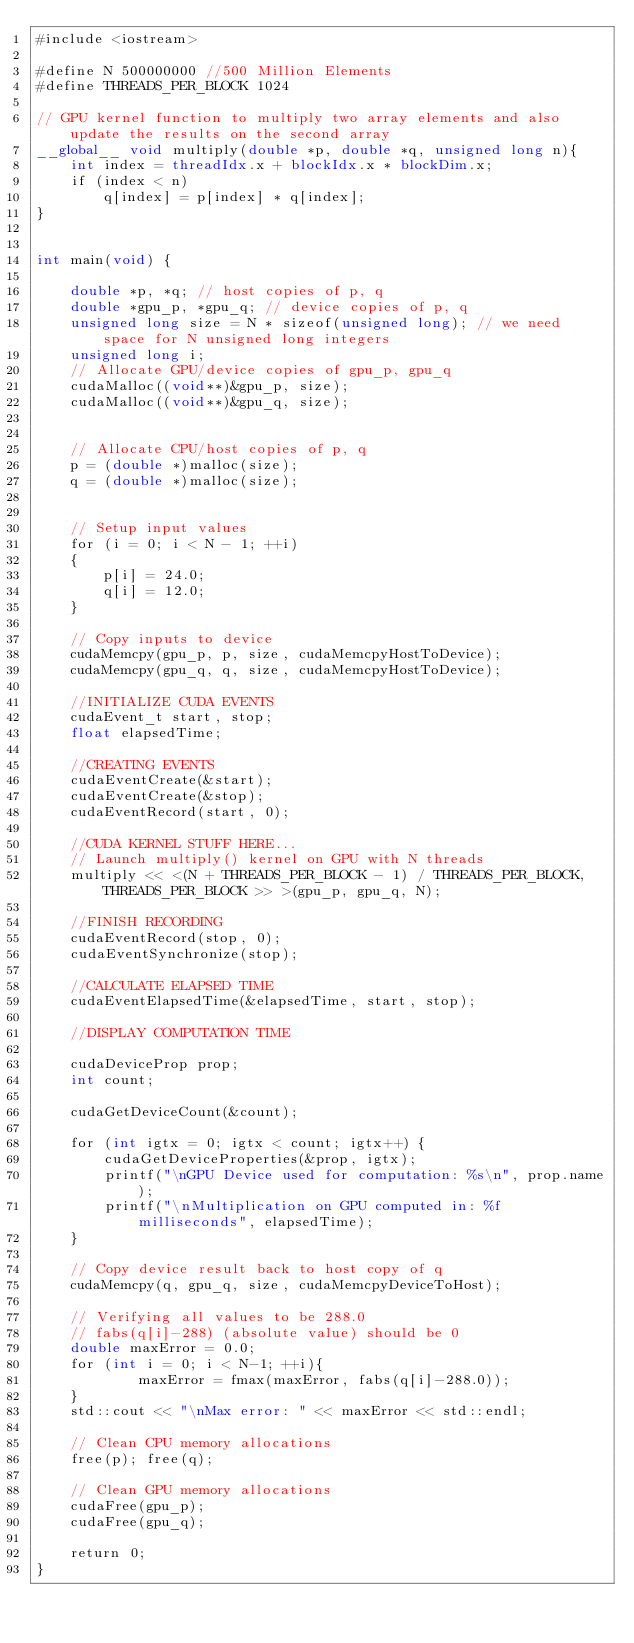Convert code to text. <code><loc_0><loc_0><loc_500><loc_500><_Cuda_>#include <iostream>

#define N 500000000 //500 Million Elements
#define THREADS_PER_BLOCK 1024

// GPU kernel function to multiply two array elements and also update the results on the second array
__global__ void multiply(double *p, double *q, unsigned long n){
	int index = threadIdx.x + blockIdx.x * blockDim.x;
	if (index < n)
		q[index] = p[index] * q[index];
}


int main(void) {

	double *p, *q; // host copies of p, q
	double *gpu_p, *gpu_q; // device copies of p, q
	unsigned long size = N * sizeof(unsigned long); // we need space for N unsigned long integers
	unsigned long i;
	// Allocate GPU/device copies of gpu_p, gpu_q
	cudaMalloc((void**)&gpu_p, size);
	cudaMalloc((void**)&gpu_q, size);


	// Allocate CPU/host copies of p, q
	p = (double *)malloc(size);
	q = (double *)malloc(size);


	// Setup input values
	for (i = 0; i < N - 1; ++i)
	{
		p[i] = 24.0;
		q[i] = 12.0;
	}

	// Copy inputs to device
	cudaMemcpy(gpu_p, p, size, cudaMemcpyHostToDevice);
	cudaMemcpy(gpu_q, q, size, cudaMemcpyHostToDevice);

	//INITIALIZE CUDA EVENTS
	cudaEvent_t start, stop;
	float elapsedTime; 

	//CREATING EVENTS
	cudaEventCreate(&start);
	cudaEventCreate(&stop);
	cudaEventRecord(start, 0);

	//CUDA KERNEL STUFF HERE...
	// Launch multiply() kernel on GPU with N threads
	multiply << <(N + THREADS_PER_BLOCK - 1) / THREADS_PER_BLOCK, THREADS_PER_BLOCK >> >(gpu_p, gpu_q, N);

	//FINISH RECORDING
	cudaEventRecord(stop, 0);
	cudaEventSynchronize(stop);

	//CALCULATE ELAPSED TIME
	cudaEventElapsedTime(&elapsedTime, start, stop);

	//DISPLAY COMPUTATION TIME
	
	cudaDeviceProp prop;
	int count;

	cudaGetDeviceCount(&count);

	for (int igtx = 0; igtx < count; igtx++) {
		cudaGetDeviceProperties(&prop, igtx);
		printf("\nGPU Device used for computation: %s\n", prop.name);
		printf("\nMultiplication on GPU computed in: %f milliseconds", elapsedTime);
	}
	
	// Copy device result back to host copy of q
	cudaMemcpy(q, gpu_q, size, cudaMemcpyDeviceToHost);
	
	// Verifying all values to be 288.0
  	// fabs(q[i]-288) (absolute value) should be 0
	double maxError = 0.0;
	for (int i = 0; i < N-1; ++i){
    		maxError = fmax(maxError, fabs(q[i]-288.0));
	}
  	std::cout << "\nMax error: " << maxError << std::endl;

	// Clean CPU memory allocations
	free(p); free(q); 

	// Clean GPU memory allocations
	cudaFree(gpu_p);
	cudaFree(gpu_q);
	
	return 0;
}
</code> 